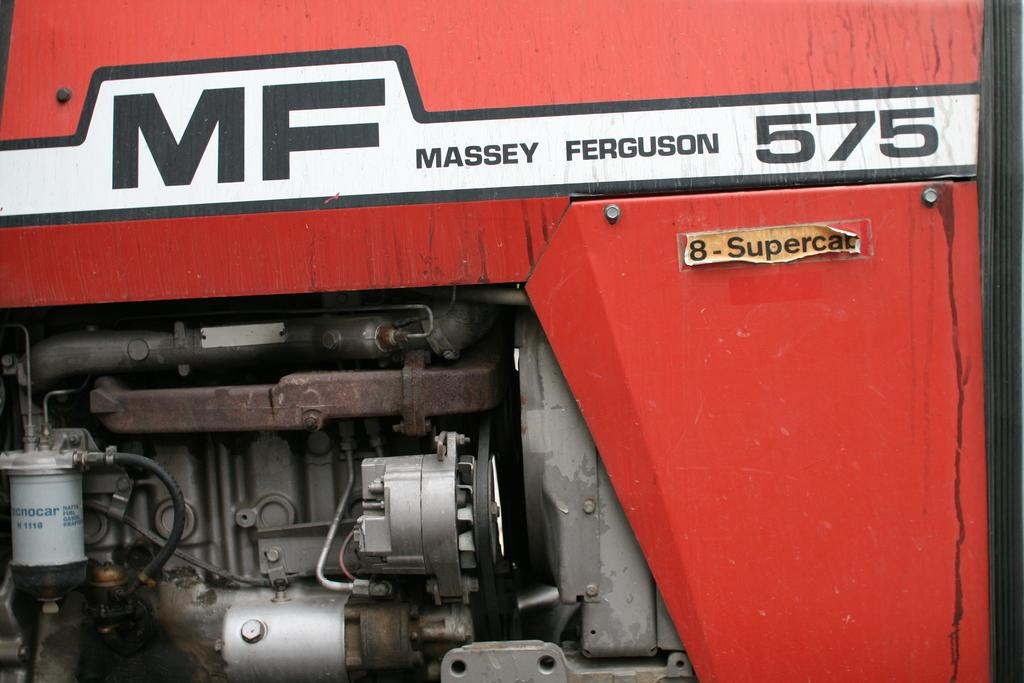What can be found in the image that is used for decoration or labeling? There are stickers in the image. What type of machinery is present in the image? There is an engine in the image. Can you describe the unspecified objects in the image? Unfortunately, the provided facts do not give any details about the unspecified objects in the image. What type of clam is visible in the image? There is no clam present in the image. How does the sleet affect the stickers in the image? There is no mention of sleet in the provided facts, so we cannot determine its effect on the stickers in the image. 